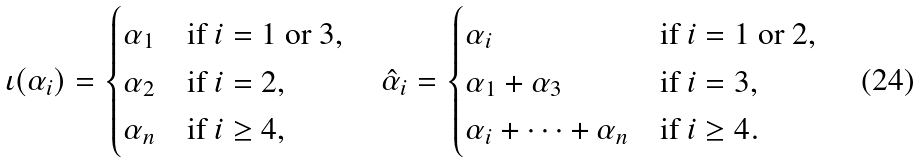Convert formula to latex. <formula><loc_0><loc_0><loc_500><loc_500>\iota ( \alpha _ { i } ) = \begin{cases} \alpha _ { 1 } & \text {if } i = 1 \text { or } 3 , \\ \alpha _ { 2 } & \text {if } i = 2 , \\ \alpha _ { n } & \text {if } i \geq 4 , \end{cases} \quad \hat { \alpha } _ { i } = \begin{cases} \alpha _ { i } & \text {if } i = 1 \text { or } 2 , \\ \alpha _ { 1 } + \alpha _ { 3 } & \text {if } i = 3 , \\ \alpha _ { i } + \cdots + \alpha _ { n } & \text {if } i \geq 4 . \end{cases}</formula> 